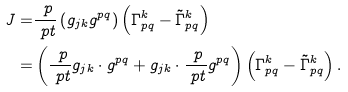Convert formula to latex. <formula><loc_0><loc_0><loc_500><loc_500>J = & \frac { \ p } { \ p t } \left ( g _ { j k } g ^ { p q } \right ) \left ( \Gamma _ { p q } ^ { k } - \tilde { \Gamma } _ { p q } ^ { k } \right ) \\ = & \left ( \frac { \ p } { \ p t } g _ { j k } \cdot g ^ { p q } + g _ { j k } \cdot \frac { \ p } { \ p t } g ^ { p q } \right ) \left ( \Gamma _ { p q } ^ { k } - \tilde { \Gamma } _ { p q } ^ { k } \right ) . \\</formula> 